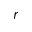Convert formula to latex. <formula><loc_0><loc_0><loc_500><loc_500>r</formula> 